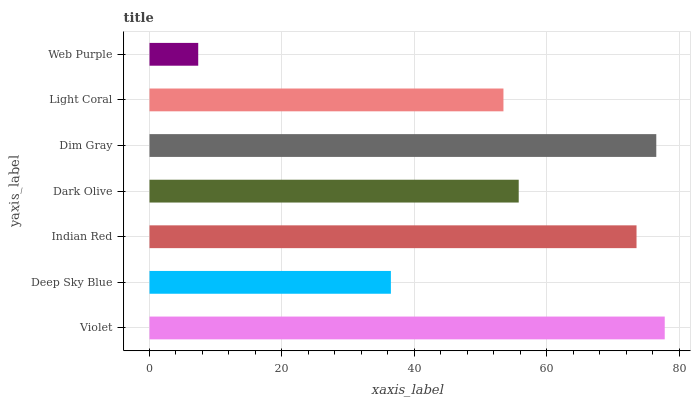Is Web Purple the minimum?
Answer yes or no. Yes. Is Violet the maximum?
Answer yes or no. Yes. Is Deep Sky Blue the minimum?
Answer yes or no. No. Is Deep Sky Blue the maximum?
Answer yes or no. No. Is Violet greater than Deep Sky Blue?
Answer yes or no. Yes. Is Deep Sky Blue less than Violet?
Answer yes or no. Yes. Is Deep Sky Blue greater than Violet?
Answer yes or no. No. Is Violet less than Deep Sky Blue?
Answer yes or no. No. Is Dark Olive the high median?
Answer yes or no. Yes. Is Dark Olive the low median?
Answer yes or no. Yes. Is Web Purple the high median?
Answer yes or no. No. Is Deep Sky Blue the low median?
Answer yes or no. No. 